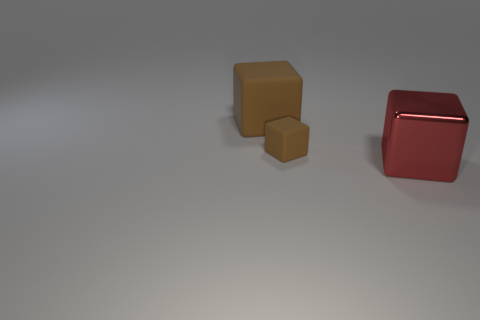Add 1 big brown matte objects. How many objects exist? 4 Subtract 0 yellow cylinders. How many objects are left? 3 Subtract all tiny rubber balls. Subtract all brown objects. How many objects are left? 1 Add 2 large shiny things. How many large shiny things are left? 3 Add 3 red metallic cubes. How many red metallic cubes exist? 4 